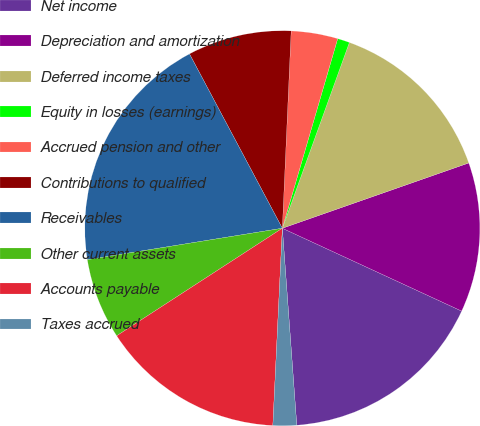<chart> <loc_0><loc_0><loc_500><loc_500><pie_chart><fcel>Net income<fcel>Depreciation and amortization<fcel>Deferred income taxes<fcel>Equity in losses (earnings)<fcel>Accrued pension and other<fcel>Contributions to qualified<fcel>Receivables<fcel>Other current assets<fcel>Accounts payable<fcel>Taxes accrued<nl><fcel>16.95%<fcel>12.25%<fcel>14.13%<fcel>0.99%<fcel>3.81%<fcel>8.5%<fcel>19.76%<fcel>6.62%<fcel>15.07%<fcel>1.93%<nl></chart> 